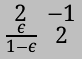Convert formula to latex. <formula><loc_0><loc_0><loc_500><loc_500>\begin{smallmatrix} 2 & - 1 \\ \frac { \epsilon } { 1 - \epsilon } & 2 \end{smallmatrix}</formula> 